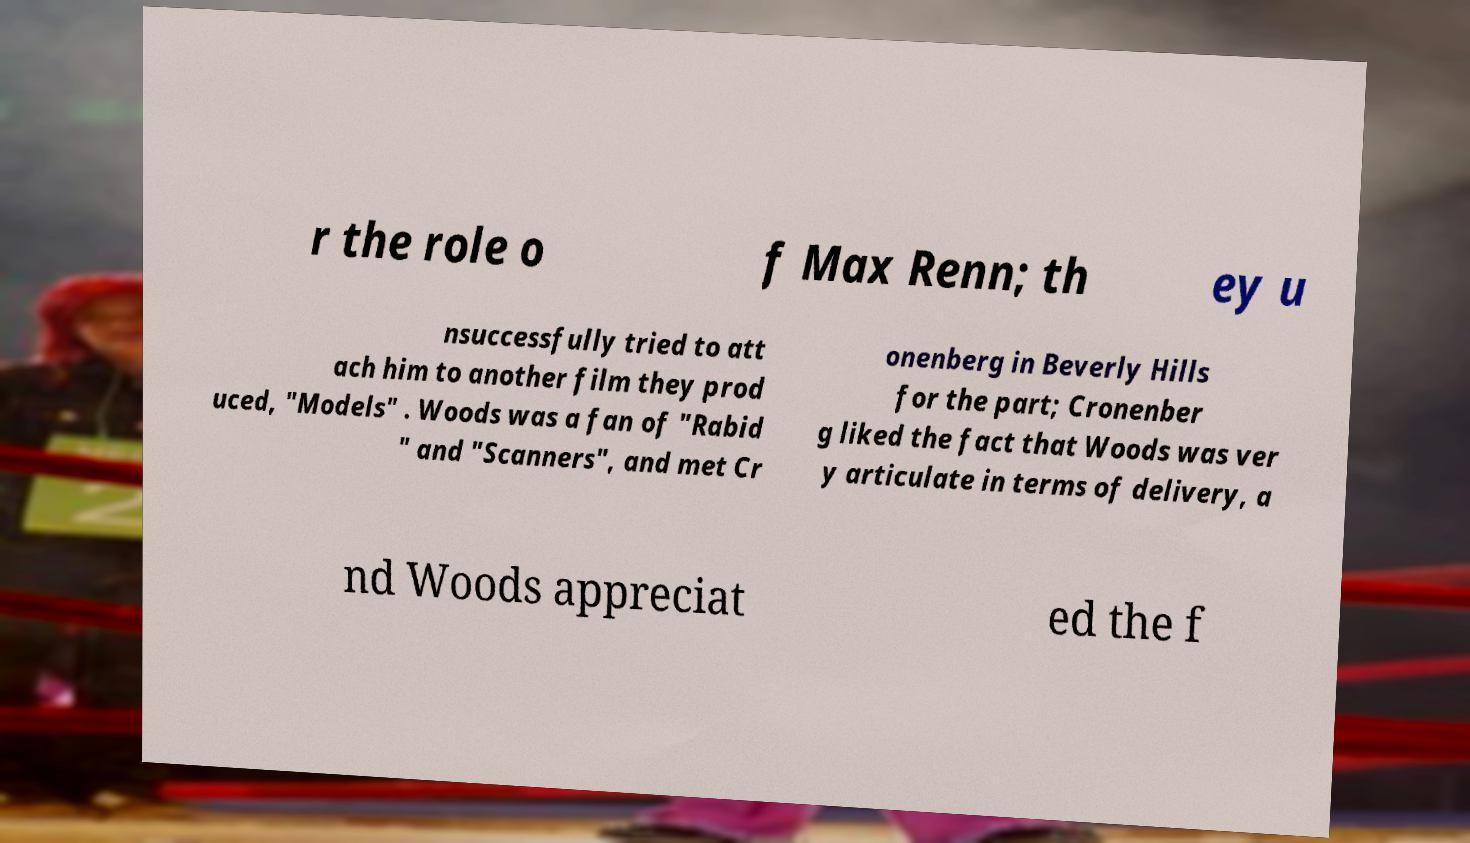Could you extract and type out the text from this image? r the role o f Max Renn; th ey u nsuccessfully tried to att ach him to another film they prod uced, "Models" . Woods was a fan of "Rabid " and "Scanners", and met Cr onenberg in Beverly Hills for the part; Cronenber g liked the fact that Woods was ver y articulate in terms of delivery, a nd Woods appreciat ed the f 